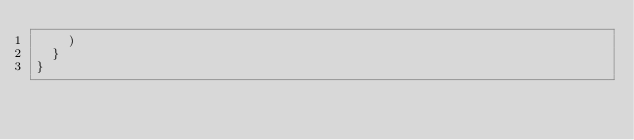Convert code to text. <code><loc_0><loc_0><loc_500><loc_500><_JavaScript_>    )
  }
}</code> 